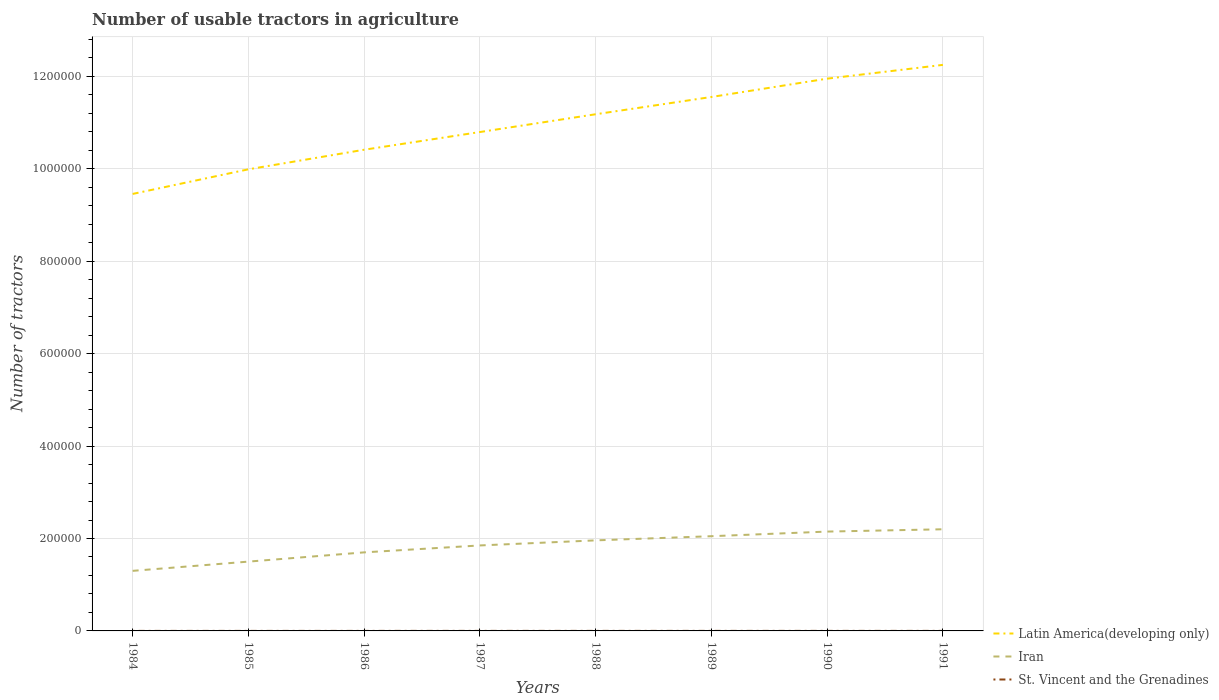How many different coloured lines are there?
Provide a short and direct response. 3. What is the total number of usable tractors in agriculture in Latin America(developing only) in the graph?
Give a very brief answer. -6.95e+04. What is the difference between the highest and the second highest number of usable tractors in agriculture in Iran?
Your answer should be compact. 9.00e+04. What is the difference between the highest and the lowest number of usable tractors in agriculture in St. Vincent and the Grenadines?
Keep it short and to the point. 4. How many lines are there?
Provide a succinct answer. 3. How many years are there in the graph?
Make the answer very short. 8. Does the graph contain grids?
Your answer should be very brief. Yes. How many legend labels are there?
Offer a very short reply. 3. What is the title of the graph?
Offer a very short reply. Number of usable tractors in agriculture. Does "Sub-Saharan Africa (developing only)" appear as one of the legend labels in the graph?
Offer a very short reply. No. What is the label or title of the X-axis?
Provide a succinct answer. Years. What is the label or title of the Y-axis?
Keep it short and to the point. Number of tractors. What is the Number of tractors of Latin America(developing only) in 1984?
Ensure brevity in your answer.  9.46e+05. What is the Number of tractors of Latin America(developing only) in 1985?
Offer a very short reply. 9.99e+05. What is the Number of tractors of Iran in 1985?
Make the answer very short. 1.50e+05. What is the Number of tractors of Latin America(developing only) in 1986?
Your answer should be very brief. 1.04e+06. What is the Number of tractors of Iran in 1986?
Provide a succinct answer. 1.70e+05. What is the Number of tractors of Latin America(developing only) in 1987?
Your answer should be compact. 1.08e+06. What is the Number of tractors in Iran in 1987?
Give a very brief answer. 1.85e+05. What is the Number of tractors in Latin America(developing only) in 1988?
Offer a very short reply. 1.12e+06. What is the Number of tractors of Iran in 1988?
Keep it short and to the point. 1.96e+05. What is the Number of tractors in Latin America(developing only) in 1989?
Ensure brevity in your answer.  1.16e+06. What is the Number of tractors of Iran in 1989?
Offer a terse response. 2.05e+05. What is the Number of tractors in St. Vincent and the Grenadines in 1989?
Keep it short and to the point. 87. What is the Number of tractors of Latin America(developing only) in 1990?
Make the answer very short. 1.20e+06. What is the Number of tractors in Iran in 1990?
Provide a short and direct response. 2.15e+05. What is the Number of tractors in St. Vincent and the Grenadines in 1990?
Your answer should be compact. 89. What is the Number of tractors of Latin America(developing only) in 1991?
Provide a short and direct response. 1.23e+06. What is the Number of tractors of Iran in 1991?
Provide a short and direct response. 2.20e+05. What is the Number of tractors in St. Vincent and the Grenadines in 1991?
Give a very brief answer. 91. Across all years, what is the maximum Number of tractors of Latin America(developing only)?
Offer a terse response. 1.23e+06. Across all years, what is the maximum Number of tractors in St. Vincent and the Grenadines?
Offer a very short reply. 91. Across all years, what is the minimum Number of tractors of Latin America(developing only)?
Offer a very short reply. 9.46e+05. Across all years, what is the minimum Number of tractors in St. Vincent and the Grenadines?
Give a very brief answer. 80. What is the total Number of tractors of Latin America(developing only) in the graph?
Provide a short and direct response. 8.76e+06. What is the total Number of tractors of Iran in the graph?
Provide a succinct answer. 1.47e+06. What is the total Number of tractors in St. Vincent and the Grenadines in the graph?
Give a very brief answer. 681. What is the difference between the Number of tractors in Latin America(developing only) in 1984 and that in 1985?
Provide a succinct answer. -5.33e+04. What is the difference between the Number of tractors in Iran in 1984 and that in 1985?
Give a very brief answer. -2.00e+04. What is the difference between the Number of tractors in St. Vincent and the Grenadines in 1984 and that in 1985?
Ensure brevity in your answer.  -1. What is the difference between the Number of tractors of Latin America(developing only) in 1984 and that in 1986?
Give a very brief answer. -9.57e+04. What is the difference between the Number of tractors in Iran in 1984 and that in 1986?
Make the answer very short. -4.00e+04. What is the difference between the Number of tractors of St. Vincent and the Grenadines in 1984 and that in 1986?
Make the answer very short. -3. What is the difference between the Number of tractors in Latin America(developing only) in 1984 and that in 1987?
Offer a very short reply. -1.34e+05. What is the difference between the Number of tractors in Iran in 1984 and that in 1987?
Make the answer very short. -5.50e+04. What is the difference between the Number of tractors of Latin America(developing only) in 1984 and that in 1988?
Offer a terse response. -1.72e+05. What is the difference between the Number of tractors in Iran in 1984 and that in 1988?
Make the answer very short. -6.60e+04. What is the difference between the Number of tractors in Latin America(developing only) in 1984 and that in 1989?
Keep it short and to the point. -2.10e+05. What is the difference between the Number of tractors of Iran in 1984 and that in 1989?
Ensure brevity in your answer.  -7.50e+04. What is the difference between the Number of tractors of Latin America(developing only) in 1984 and that in 1990?
Ensure brevity in your answer.  -2.49e+05. What is the difference between the Number of tractors of Iran in 1984 and that in 1990?
Provide a succinct answer. -8.50e+04. What is the difference between the Number of tractors in St. Vincent and the Grenadines in 1984 and that in 1990?
Offer a very short reply. -9. What is the difference between the Number of tractors of Latin America(developing only) in 1984 and that in 1991?
Make the answer very short. -2.79e+05. What is the difference between the Number of tractors in Latin America(developing only) in 1985 and that in 1986?
Offer a very short reply. -4.24e+04. What is the difference between the Number of tractors of Latin America(developing only) in 1985 and that in 1987?
Your answer should be very brief. -8.07e+04. What is the difference between the Number of tractors in Iran in 1985 and that in 1987?
Offer a terse response. -3.50e+04. What is the difference between the Number of tractors in St. Vincent and the Grenadines in 1985 and that in 1987?
Your answer should be compact. -3. What is the difference between the Number of tractors in Latin America(developing only) in 1985 and that in 1988?
Ensure brevity in your answer.  -1.19e+05. What is the difference between the Number of tractors in Iran in 1985 and that in 1988?
Give a very brief answer. -4.60e+04. What is the difference between the Number of tractors in St. Vincent and the Grenadines in 1985 and that in 1988?
Offer a very short reply. -5. What is the difference between the Number of tractors of Latin America(developing only) in 1985 and that in 1989?
Offer a very short reply. -1.57e+05. What is the difference between the Number of tractors in Iran in 1985 and that in 1989?
Provide a short and direct response. -5.50e+04. What is the difference between the Number of tractors of Latin America(developing only) in 1985 and that in 1990?
Make the answer very short. -1.96e+05. What is the difference between the Number of tractors of Iran in 1985 and that in 1990?
Provide a short and direct response. -6.50e+04. What is the difference between the Number of tractors of St. Vincent and the Grenadines in 1985 and that in 1990?
Your answer should be compact. -8. What is the difference between the Number of tractors in Latin America(developing only) in 1985 and that in 1991?
Ensure brevity in your answer.  -2.26e+05. What is the difference between the Number of tractors of Latin America(developing only) in 1986 and that in 1987?
Your answer should be very brief. -3.83e+04. What is the difference between the Number of tractors in Iran in 1986 and that in 1987?
Offer a very short reply. -1.50e+04. What is the difference between the Number of tractors in Latin America(developing only) in 1986 and that in 1988?
Provide a short and direct response. -7.68e+04. What is the difference between the Number of tractors in Iran in 1986 and that in 1988?
Offer a very short reply. -2.60e+04. What is the difference between the Number of tractors in Latin America(developing only) in 1986 and that in 1989?
Provide a short and direct response. -1.14e+05. What is the difference between the Number of tractors in Iran in 1986 and that in 1989?
Provide a short and direct response. -3.50e+04. What is the difference between the Number of tractors in St. Vincent and the Grenadines in 1986 and that in 1989?
Your answer should be compact. -4. What is the difference between the Number of tractors in Latin America(developing only) in 1986 and that in 1990?
Offer a very short reply. -1.54e+05. What is the difference between the Number of tractors in Iran in 1986 and that in 1990?
Provide a short and direct response. -4.50e+04. What is the difference between the Number of tractors of St. Vincent and the Grenadines in 1986 and that in 1990?
Provide a succinct answer. -6. What is the difference between the Number of tractors of Latin America(developing only) in 1986 and that in 1991?
Your answer should be compact. -1.84e+05. What is the difference between the Number of tractors of Latin America(developing only) in 1987 and that in 1988?
Give a very brief answer. -3.85e+04. What is the difference between the Number of tractors of Iran in 1987 and that in 1988?
Make the answer very short. -1.10e+04. What is the difference between the Number of tractors of Latin America(developing only) in 1987 and that in 1989?
Give a very brief answer. -7.59e+04. What is the difference between the Number of tractors of St. Vincent and the Grenadines in 1987 and that in 1989?
Provide a succinct answer. -3. What is the difference between the Number of tractors of Latin America(developing only) in 1987 and that in 1990?
Your answer should be compact. -1.16e+05. What is the difference between the Number of tractors in St. Vincent and the Grenadines in 1987 and that in 1990?
Your answer should be compact. -5. What is the difference between the Number of tractors of Latin America(developing only) in 1987 and that in 1991?
Your answer should be compact. -1.45e+05. What is the difference between the Number of tractors of Iran in 1987 and that in 1991?
Make the answer very short. -3.50e+04. What is the difference between the Number of tractors of St. Vincent and the Grenadines in 1987 and that in 1991?
Offer a very short reply. -7. What is the difference between the Number of tractors of Latin America(developing only) in 1988 and that in 1989?
Your answer should be compact. -3.74e+04. What is the difference between the Number of tractors of Iran in 1988 and that in 1989?
Offer a terse response. -9019. What is the difference between the Number of tractors of Latin America(developing only) in 1988 and that in 1990?
Make the answer very short. -7.70e+04. What is the difference between the Number of tractors in Iran in 1988 and that in 1990?
Your answer should be compact. -1.90e+04. What is the difference between the Number of tractors of St. Vincent and the Grenadines in 1988 and that in 1990?
Your answer should be very brief. -3. What is the difference between the Number of tractors in Latin America(developing only) in 1988 and that in 1991?
Keep it short and to the point. -1.07e+05. What is the difference between the Number of tractors in Iran in 1988 and that in 1991?
Provide a succinct answer. -2.40e+04. What is the difference between the Number of tractors of Latin America(developing only) in 1989 and that in 1990?
Provide a succinct answer. -3.96e+04. What is the difference between the Number of tractors in Iran in 1989 and that in 1990?
Give a very brief answer. -10000. What is the difference between the Number of tractors in Latin America(developing only) in 1989 and that in 1991?
Your answer should be compact. -6.95e+04. What is the difference between the Number of tractors of Iran in 1989 and that in 1991?
Provide a short and direct response. -1.50e+04. What is the difference between the Number of tractors in Latin America(developing only) in 1990 and that in 1991?
Make the answer very short. -2.98e+04. What is the difference between the Number of tractors in Iran in 1990 and that in 1991?
Offer a very short reply. -5000. What is the difference between the Number of tractors in St. Vincent and the Grenadines in 1990 and that in 1991?
Keep it short and to the point. -2. What is the difference between the Number of tractors of Latin America(developing only) in 1984 and the Number of tractors of Iran in 1985?
Your answer should be very brief. 7.96e+05. What is the difference between the Number of tractors of Latin America(developing only) in 1984 and the Number of tractors of St. Vincent and the Grenadines in 1985?
Give a very brief answer. 9.46e+05. What is the difference between the Number of tractors of Iran in 1984 and the Number of tractors of St. Vincent and the Grenadines in 1985?
Your answer should be compact. 1.30e+05. What is the difference between the Number of tractors of Latin America(developing only) in 1984 and the Number of tractors of Iran in 1986?
Your response must be concise. 7.76e+05. What is the difference between the Number of tractors of Latin America(developing only) in 1984 and the Number of tractors of St. Vincent and the Grenadines in 1986?
Keep it short and to the point. 9.46e+05. What is the difference between the Number of tractors in Iran in 1984 and the Number of tractors in St. Vincent and the Grenadines in 1986?
Ensure brevity in your answer.  1.30e+05. What is the difference between the Number of tractors in Latin America(developing only) in 1984 and the Number of tractors in Iran in 1987?
Give a very brief answer. 7.61e+05. What is the difference between the Number of tractors in Latin America(developing only) in 1984 and the Number of tractors in St. Vincent and the Grenadines in 1987?
Provide a succinct answer. 9.46e+05. What is the difference between the Number of tractors in Iran in 1984 and the Number of tractors in St. Vincent and the Grenadines in 1987?
Your response must be concise. 1.30e+05. What is the difference between the Number of tractors of Latin America(developing only) in 1984 and the Number of tractors of Iran in 1988?
Provide a succinct answer. 7.50e+05. What is the difference between the Number of tractors of Latin America(developing only) in 1984 and the Number of tractors of St. Vincent and the Grenadines in 1988?
Your answer should be very brief. 9.46e+05. What is the difference between the Number of tractors in Iran in 1984 and the Number of tractors in St. Vincent and the Grenadines in 1988?
Offer a terse response. 1.30e+05. What is the difference between the Number of tractors of Latin America(developing only) in 1984 and the Number of tractors of Iran in 1989?
Make the answer very short. 7.41e+05. What is the difference between the Number of tractors in Latin America(developing only) in 1984 and the Number of tractors in St. Vincent and the Grenadines in 1989?
Offer a terse response. 9.46e+05. What is the difference between the Number of tractors in Iran in 1984 and the Number of tractors in St. Vincent and the Grenadines in 1989?
Give a very brief answer. 1.30e+05. What is the difference between the Number of tractors of Latin America(developing only) in 1984 and the Number of tractors of Iran in 1990?
Your answer should be very brief. 7.31e+05. What is the difference between the Number of tractors in Latin America(developing only) in 1984 and the Number of tractors in St. Vincent and the Grenadines in 1990?
Offer a very short reply. 9.46e+05. What is the difference between the Number of tractors of Iran in 1984 and the Number of tractors of St. Vincent and the Grenadines in 1990?
Your response must be concise. 1.30e+05. What is the difference between the Number of tractors of Latin America(developing only) in 1984 and the Number of tractors of Iran in 1991?
Make the answer very short. 7.26e+05. What is the difference between the Number of tractors in Latin America(developing only) in 1984 and the Number of tractors in St. Vincent and the Grenadines in 1991?
Ensure brevity in your answer.  9.46e+05. What is the difference between the Number of tractors in Iran in 1984 and the Number of tractors in St. Vincent and the Grenadines in 1991?
Keep it short and to the point. 1.30e+05. What is the difference between the Number of tractors of Latin America(developing only) in 1985 and the Number of tractors of Iran in 1986?
Offer a very short reply. 8.29e+05. What is the difference between the Number of tractors of Latin America(developing only) in 1985 and the Number of tractors of St. Vincent and the Grenadines in 1986?
Your answer should be very brief. 9.99e+05. What is the difference between the Number of tractors of Iran in 1985 and the Number of tractors of St. Vincent and the Grenadines in 1986?
Your answer should be compact. 1.50e+05. What is the difference between the Number of tractors in Latin America(developing only) in 1985 and the Number of tractors in Iran in 1987?
Your answer should be very brief. 8.14e+05. What is the difference between the Number of tractors in Latin America(developing only) in 1985 and the Number of tractors in St. Vincent and the Grenadines in 1987?
Keep it short and to the point. 9.99e+05. What is the difference between the Number of tractors in Iran in 1985 and the Number of tractors in St. Vincent and the Grenadines in 1987?
Your answer should be compact. 1.50e+05. What is the difference between the Number of tractors of Latin America(developing only) in 1985 and the Number of tractors of Iran in 1988?
Make the answer very short. 8.03e+05. What is the difference between the Number of tractors in Latin America(developing only) in 1985 and the Number of tractors in St. Vincent and the Grenadines in 1988?
Make the answer very short. 9.99e+05. What is the difference between the Number of tractors of Iran in 1985 and the Number of tractors of St. Vincent and the Grenadines in 1988?
Offer a terse response. 1.50e+05. What is the difference between the Number of tractors of Latin America(developing only) in 1985 and the Number of tractors of Iran in 1989?
Keep it short and to the point. 7.94e+05. What is the difference between the Number of tractors of Latin America(developing only) in 1985 and the Number of tractors of St. Vincent and the Grenadines in 1989?
Your answer should be compact. 9.99e+05. What is the difference between the Number of tractors of Iran in 1985 and the Number of tractors of St. Vincent and the Grenadines in 1989?
Ensure brevity in your answer.  1.50e+05. What is the difference between the Number of tractors in Latin America(developing only) in 1985 and the Number of tractors in Iran in 1990?
Provide a succinct answer. 7.84e+05. What is the difference between the Number of tractors of Latin America(developing only) in 1985 and the Number of tractors of St. Vincent and the Grenadines in 1990?
Make the answer very short. 9.99e+05. What is the difference between the Number of tractors of Iran in 1985 and the Number of tractors of St. Vincent and the Grenadines in 1990?
Give a very brief answer. 1.50e+05. What is the difference between the Number of tractors of Latin America(developing only) in 1985 and the Number of tractors of Iran in 1991?
Keep it short and to the point. 7.79e+05. What is the difference between the Number of tractors in Latin America(developing only) in 1985 and the Number of tractors in St. Vincent and the Grenadines in 1991?
Your answer should be compact. 9.99e+05. What is the difference between the Number of tractors in Iran in 1985 and the Number of tractors in St. Vincent and the Grenadines in 1991?
Offer a very short reply. 1.50e+05. What is the difference between the Number of tractors in Latin America(developing only) in 1986 and the Number of tractors in Iran in 1987?
Provide a short and direct response. 8.56e+05. What is the difference between the Number of tractors in Latin America(developing only) in 1986 and the Number of tractors in St. Vincent and the Grenadines in 1987?
Offer a very short reply. 1.04e+06. What is the difference between the Number of tractors of Iran in 1986 and the Number of tractors of St. Vincent and the Grenadines in 1987?
Ensure brevity in your answer.  1.70e+05. What is the difference between the Number of tractors in Latin America(developing only) in 1986 and the Number of tractors in Iran in 1988?
Your answer should be compact. 8.45e+05. What is the difference between the Number of tractors in Latin America(developing only) in 1986 and the Number of tractors in St. Vincent and the Grenadines in 1988?
Offer a terse response. 1.04e+06. What is the difference between the Number of tractors in Iran in 1986 and the Number of tractors in St. Vincent and the Grenadines in 1988?
Give a very brief answer. 1.70e+05. What is the difference between the Number of tractors in Latin America(developing only) in 1986 and the Number of tractors in Iran in 1989?
Give a very brief answer. 8.36e+05. What is the difference between the Number of tractors in Latin America(developing only) in 1986 and the Number of tractors in St. Vincent and the Grenadines in 1989?
Provide a short and direct response. 1.04e+06. What is the difference between the Number of tractors of Iran in 1986 and the Number of tractors of St. Vincent and the Grenadines in 1989?
Give a very brief answer. 1.70e+05. What is the difference between the Number of tractors of Latin America(developing only) in 1986 and the Number of tractors of Iran in 1990?
Make the answer very short. 8.26e+05. What is the difference between the Number of tractors of Latin America(developing only) in 1986 and the Number of tractors of St. Vincent and the Grenadines in 1990?
Give a very brief answer. 1.04e+06. What is the difference between the Number of tractors in Iran in 1986 and the Number of tractors in St. Vincent and the Grenadines in 1990?
Provide a succinct answer. 1.70e+05. What is the difference between the Number of tractors of Latin America(developing only) in 1986 and the Number of tractors of Iran in 1991?
Your answer should be compact. 8.21e+05. What is the difference between the Number of tractors of Latin America(developing only) in 1986 and the Number of tractors of St. Vincent and the Grenadines in 1991?
Make the answer very short. 1.04e+06. What is the difference between the Number of tractors of Iran in 1986 and the Number of tractors of St. Vincent and the Grenadines in 1991?
Your response must be concise. 1.70e+05. What is the difference between the Number of tractors in Latin America(developing only) in 1987 and the Number of tractors in Iran in 1988?
Offer a terse response. 8.84e+05. What is the difference between the Number of tractors in Latin America(developing only) in 1987 and the Number of tractors in St. Vincent and the Grenadines in 1988?
Make the answer very short. 1.08e+06. What is the difference between the Number of tractors in Iran in 1987 and the Number of tractors in St. Vincent and the Grenadines in 1988?
Keep it short and to the point. 1.85e+05. What is the difference between the Number of tractors in Latin America(developing only) in 1987 and the Number of tractors in Iran in 1989?
Ensure brevity in your answer.  8.75e+05. What is the difference between the Number of tractors in Latin America(developing only) in 1987 and the Number of tractors in St. Vincent and the Grenadines in 1989?
Provide a short and direct response. 1.08e+06. What is the difference between the Number of tractors of Iran in 1987 and the Number of tractors of St. Vincent and the Grenadines in 1989?
Your answer should be very brief. 1.85e+05. What is the difference between the Number of tractors in Latin America(developing only) in 1987 and the Number of tractors in Iran in 1990?
Offer a very short reply. 8.65e+05. What is the difference between the Number of tractors in Latin America(developing only) in 1987 and the Number of tractors in St. Vincent and the Grenadines in 1990?
Offer a terse response. 1.08e+06. What is the difference between the Number of tractors in Iran in 1987 and the Number of tractors in St. Vincent and the Grenadines in 1990?
Offer a terse response. 1.85e+05. What is the difference between the Number of tractors in Latin America(developing only) in 1987 and the Number of tractors in Iran in 1991?
Provide a short and direct response. 8.60e+05. What is the difference between the Number of tractors of Latin America(developing only) in 1987 and the Number of tractors of St. Vincent and the Grenadines in 1991?
Provide a succinct answer. 1.08e+06. What is the difference between the Number of tractors in Iran in 1987 and the Number of tractors in St. Vincent and the Grenadines in 1991?
Give a very brief answer. 1.85e+05. What is the difference between the Number of tractors of Latin America(developing only) in 1988 and the Number of tractors of Iran in 1989?
Your answer should be compact. 9.13e+05. What is the difference between the Number of tractors in Latin America(developing only) in 1988 and the Number of tractors in St. Vincent and the Grenadines in 1989?
Provide a succinct answer. 1.12e+06. What is the difference between the Number of tractors in Iran in 1988 and the Number of tractors in St. Vincent and the Grenadines in 1989?
Provide a short and direct response. 1.96e+05. What is the difference between the Number of tractors of Latin America(developing only) in 1988 and the Number of tractors of Iran in 1990?
Your answer should be very brief. 9.03e+05. What is the difference between the Number of tractors of Latin America(developing only) in 1988 and the Number of tractors of St. Vincent and the Grenadines in 1990?
Ensure brevity in your answer.  1.12e+06. What is the difference between the Number of tractors of Iran in 1988 and the Number of tractors of St. Vincent and the Grenadines in 1990?
Offer a very short reply. 1.96e+05. What is the difference between the Number of tractors of Latin America(developing only) in 1988 and the Number of tractors of Iran in 1991?
Keep it short and to the point. 8.98e+05. What is the difference between the Number of tractors in Latin America(developing only) in 1988 and the Number of tractors in St. Vincent and the Grenadines in 1991?
Offer a very short reply. 1.12e+06. What is the difference between the Number of tractors in Iran in 1988 and the Number of tractors in St. Vincent and the Grenadines in 1991?
Your response must be concise. 1.96e+05. What is the difference between the Number of tractors in Latin America(developing only) in 1989 and the Number of tractors in Iran in 1990?
Give a very brief answer. 9.41e+05. What is the difference between the Number of tractors of Latin America(developing only) in 1989 and the Number of tractors of St. Vincent and the Grenadines in 1990?
Make the answer very short. 1.16e+06. What is the difference between the Number of tractors of Iran in 1989 and the Number of tractors of St. Vincent and the Grenadines in 1990?
Offer a terse response. 2.05e+05. What is the difference between the Number of tractors in Latin America(developing only) in 1989 and the Number of tractors in Iran in 1991?
Your answer should be compact. 9.36e+05. What is the difference between the Number of tractors in Latin America(developing only) in 1989 and the Number of tractors in St. Vincent and the Grenadines in 1991?
Give a very brief answer. 1.16e+06. What is the difference between the Number of tractors of Iran in 1989 and the Number of tractors of St. Vincent and the Grenadines in 1991?
Offer a very short reply. 2.05e+05. What is the difference between the Number of tractors of Latin America(developing only) in 1990 and the Number of tractors of Iran in 1991?
Your answer should be compact. 9.75e+05. What is the difference between the Number of tractors in Latin America(developing only) in 1990 and the Number of tractors in St. Vincent and the Grenadines in 1991?
Offer a terse response. 1.20e+06. What is the difference between the Number of tractors in Iran in 1990 and the Number of tractors in St. Vincent and the Grenadines in 1991?
Provide a short and direct response. 2.15e+05. What is the average Number of tractors of Latin America(developing only) per year?
Provide a succinct answer. 1.10e+06. What is the average Number of tractors of Iran per year?
Offer a terse response. 1.84e+05. What is the average Number of tractors in St. Vincent and the Grenadines per year?
Your answer should be very brief. 85.12. In the year 1984, what is the difference between the Number of tractors of Latin America(developing only) and Number of tractors of Iran?
Offer a terse response. 8.16e+05. In the year 1984, what is the difference between the Number of tractors of Latin America(developing only) and Number of tractors of St. Vincent and the Grenadines?
Keep it short and to the point. 9.46e+05. In the year 1984, what is the difference between the Number of tractors of Iran and Number of tractors of St. Vincent and the Grenadines?
Offer a terse response. 1.30e+05. In the year 1985, what is the difference between the Number of tractors of Latin America(developing only) and Number of tractors of Iran?
Your response must be concise. 8.49e+05. In the year 1985, what is the difference between the Number of tractors of Latin America(developing only) and Number of tractors of St. Vincent and the Grenadines?
Provide a succinct answer. 9.99e+05. In the year 1985, what is the difference between the Number of tractors in Iran and Number of tractors in St. Vincent and the Grenadines?
Make the answer very short. 1.50e+05. In the year 1986, what is the difference between the Number of tractors in Latin America(developing only) and Number of tractors in Iran?
Offer a very short reply. 8.71e+05. In the year 1986, what is the difference between the Number of tractors in Latin America(developing only) and Number of tractors in St. Vincent and the Grenadines?
Your response must be concise. 1.04e+06. In the year 1986, what is the difference between the Number of tractors of Iran and Number of tractors of St. Vincent and the Grenadines?
Make the answer very short. 1.70e+05. In the year 1987, what is the difference between the Number of tractors in Latin America(developing only) and Number of tractors in Iran?
Your answer should be very brief. 8.95e+05. In the year 1987, what is the difference between the Number of tractors in Latin America(developing only) and Number of tractors in St. Vincent and the Grenadines?
Provide a short and direct response. 1.08e+06. In the year 1987, what is the difference between the Number of tractors of Iran and Number of tractors of St. Vincent and the Grenadines?
Offer a terse response. 1.85e+05. In the year 1988, what is the difference between the Number of tractors in Latin America(developing only) and Number of tractors in Iran?
Give a very brief answer. 9.22e+05. In the year 1988, what is the difference between the Number of tractors in Latin America(developing only) and Number of tractors in St. Vincent and the Grenadines?
Your answer should be very brief. 1.12e+06. In the year 1988, what is the difference between the Number of tractors in Iran and Number of tractors in St. Vincent and the Grenadines?
Your response must be concise. 1.96e+05. In the year 1989, what is the difference between the Number of tractors of Latin America(developing only) and Number of tractors of Iran?
Offer a terse response. 9.51e+05. In the year 1989, what is the difference between the Number of tractors of Latin America(developing only) and Number of tractors of St. Vincent and the Grenadines?
Provide a short and direct response. 1.16e+06. In the year 1989, what is the difference between the Number of tractors in Iran and Number of tractors in St. Vincent and the Grenadines?
Your answer should be very brief. 2.05e+05. In the year 1990, what is the difference between the Number of tractors of Latin America(developing only) and Number of tractors of Iran?
Offer a very short reply. 9.80e+05. In the year 1990, what is the difference between the Number of tractors in Latin America(developing only) and Number of tractors in St. Vincent and the Grenadines?
Your answer should be compact. 1.20e+06. In the year 1990, what is the difference between the Number of tractors in Iran and Number of tractors in St. Vincent and the Grenadines?
Provide a succinct answer. 2.15e+05. In the year 1991, what is the difference between the Number of tractors in Latin America(developing only) and Number of tractors in Iran?
Offer a very short reply. 1.01e+06. In the year 1991, what is the difference between the Number of tractors in Latin America(developing only) and Number of tractors in St. Vincent and the Grenadines?
Offer a terse response. 1.22e+06. In the year 1991, what is the difference between the Number of tractors in Iran and Number of tractors in St. Vincent and the Grenadines?
Your response must be concise. 2.20e+05. What is the ratio of the Number of tractors of Latin America(developing only) in 1984 to that in 1985?
Make the answer very short. 0.95. What is the ratio of the Number of tractors of Iran in 1984 to that in 1985?
Your answer should be compact. 0.87. What is the ratio of the Number of tractors of St. Vincent and the Grenadines in 1984 to that in 1985?
Your answer should be very brief. 0.99. What is the ratio of the Number of tractors of Latin America(developing only) in 1984 to that in 1986?
Your response must be concise. 0.91. What is the ratio of the Number of tractors of Iran in 1984 to that in 1986?
Your response must be concise. 0.76. What is the ratio of the Number of tractors in St. Vincent and the Grenadines in 1984 to that in 1986?
Make the answer very short. 0.96. What is the ratio of the Number of tractors in Latin America(developing only) in 1984 to that in 1987?
Offer a very short reply. 0.88. What is the ratio of the Number of tractors of Iran in 1984 to that in 1987?
Your answer should be compact. 0.7. What is the ratio of the Number of tractors of St. Vincent and the Grenadines in 1984 to that in 1987?
Your answer should be compact. 0.95. What is the ratio of the Number of tractors in Latin America(developing only) in 1984 to that in 1988?
Ensure brevity in your answer.  0.85. What is the ratio of the Number of tractors of Iran in 1984 to that in 1988?
Give a very brief answer. 0.66. What is the ratio of the Number of tractors in St. Vincent and the Grenadines in 1984 to that in 1988?
Ensure brevity in your answer.  0.93. What is the ratio of the Number of tractors in Latin America(developing only) in 1984 to that in 1989?
Make the answer very short. 0.82. What is the ratio of the Number of tractors of Iran in 1984 to that in 1989?
Offer a terse response. 0.63. What is the ratio of the Number of tractors in St. Vincent and the Grenadines in 1984 to that in 1989?
Provide a succinct answer. 0.92. What is the ratio of the Number of tractors in Latin America(developing only) in 1984 to that in 1990?
Your answer should be very brief. 0.79. What is the ratio of the Number of tractors in Iran in 1984 to that in 1990?
Your answer should be very brief. 0.6. What is the ratio of the Number of tractors in St. Vincent and the Grenadines in 1984 to that in 1990?
Ensure brevity in your answer.  0.9. What is the ratio of the Number of tractors in Latin America(developing only) in 1984 to that in 1991?
Your response must be concise. 0.77. What is the ratio of the Number of tractors of Iran in 1984 to that in 1991?
Make the answer very short. 0.59. What is the ratio of the Number of tractors in St. Vincent and the Grenadines in 1984 to that in 1991?
Give a very brief answer. 0.88. What is the ratio of the Number of tractors of Latin America(developing only) in 1985 to that in 1986?
Provide a succinct answer. 0.96. What is the ratio of the Number of tractors in Iran in 1985 to that in 1986?
Give a very brief answer. 0.88. What is the ratio of the Number of tractors in St. Vincent and the Grenadines in 1985 to that in 1986?
Give a very brief answer. 0.98. What is the ratio of the Number of tractors of Latin America(developing only) in 1985 to that in 1987?
Offer a very short reply. 0.93. What is the ratio of the Number of tractors of Iran in 1985 to that in 1987?
Offer a very short reply. 0.81. What is the ratio of the Number of tractors of Latin America(developing only) in 1985 to that in 1988?
Offer a terse response. 0.89. What is the ratio of the Number of tractors in Iran in 1985 to that in 1988?
Your answer should be very brief. 0.77. What is the ratio of the Number of tractors of St. Vincent and the Grenadines in 1985 to that in 1988?
Your answer should be compact. 0.94. What is the ratio of the Number of tractors of Latin America(developing only) in 1985 to that in 1989?
Your answer should be very brief. 0.86. What is the ratio of the Number of tractors of Iran in 1985 to that in 1989?
Give a very brief answer. 0.73. What is the ratio of the Number of tractors of St. Vincent and the Grenadines in 1985 to that in 1989?
Provide a short and direct response. 0.93. What is the ratio of the Number of tractors of Latin America(developing only) in 1985 to that in 1990?
Give a very brief answer. 0.84. What is the ratio of the Number of tractors in Iran in 1985 to that in 1990?
Make the answer very short. 0.7. What is the ratio of the Number of tractors in St. Vincent and the Grenadines in 1985 to that in 1990?
Your answer should be compact. 0.91. What is the ratio of the Number of tractors of Latin America(developing only) in 1985 to that in 1991?
Your answer should be very brief. 0.82. What is the ratio of the Number of tractors in Iran in 1985 to that in 1991?
Offer a very short reply. 0.68. What is the ratio of the Number of tractors in St. Vincent and the Grenadines in 1985 to that in 1991?
Make the answer very short. 0.89. What is the ratio of the Number of tractors in Latin America(developing only) in 1986 to that in 1987?
Provide a succinct answer. 0.96. What is the ratio of the Number of tractors of Iran in 1986 to that in 1987?
Give a very brief answer. 0.92. What is the ratio of the Number of tractors of Latin America(developing only) in 1986 to that in 1988?
Ensure brevity in your answer.  0.93. What is the ratio of the Number of tractors in Iran in 1986 to that in 1988?
Ensure brevity in your answer.  0.87. What is the ratio of the Number of tractors of St. Vincent and the Grenadines in 1986 to that in 1988?
Offer a terse response. 0.97. What is the ratio of the Number of tractors of Latin America(developing only) in 1986 to that in 1989?
Offer a very short reply. 0.9. What is the ratio of the Number of tractors in Iran in 1986 to that in 1989?
Keep it short and to the point. 0.83. What is the ratio of the Number of tractors of St. Vincent and the Grenadines in 1986 to that in 1989?
Keep it short and to the point. 0.95. What is the ratio of the Number of tractors in Latin America(developing only) in 1986 to that in 1990?
Make the answer very short. 0.87. What is the ratio of the Number of tractors of Iran in 1986 to that in 1990?
Your answer should be compact. 0.79. What is the ratio of the Number of tractors of St. Vincent and the Grenadines in 1986 to that in 1990?
Keep it short and to the point. 0.93. What is the ratio of the Number of tractors in Latin America(developing only) in 1986 to that in 1991?
Your response must be concise. 0.85. What is the ratio of the Number of tractors in Iran in 1986 to that in 1991?
Give a very brief answer. 0.77. What is the ratio of the Number of tractors of St. Vincent and the Grenadines in 1986 to that in 1991?
Offer a terse response. 0.91. What is the ratio of the Number of tractors in Latin America(developing only) in 1987 to that in 1988?
Offer a very short reply. 0.97. What is the ratio of the Number of tractors in Iran in 1987 to that in 1988?
Make the answer very short. 0.94. What is the ratio of the Number of tractors in St. Vincent and the Grenadines in 1987 to that in 1988?
Offer a terse response. 0.98. What is the ratio of the Number of tractors of Latin America(developing only) in 1987 to that in 1989?
Your answer should be very brief. 0.93. What is the ratio of the Number of tractors of Iran in 1987 to that in 1989?
Your answer should be compact. 0.9. What is the ratio of the Number of tractors in St. Vincent and the Grenadines in 1987 to that in 1989?
Offer a terse response. 0.97. What is the ratio of the Number of tractors in Latin America(developing only) in 1987 to that in 1990?
Provide a succinct answer. 0.9. What is the ratio of the Number of tractors in Iran in 1987 to that in 1990?
Your answer should be compact. 0.86. What is the ratio of the Number of tractors in St. Vincent and the Grenadines in 1987 to that in 1990?
Offer a very short reply. 0.94. What is the ratio of the Number of tractors of Latin America(developing only) in 1987 to that in 1991?
Ensure brevity in your answer.  0.88. What is the ratio of the Number of tractors of Iran in 1987 to that in 1991?
Offer a terse response. 0.84. What is the ratio of the Number of tractors of St. Vincent and the Grenadines in 1987 to that in 1991?
Your response must be concise. 0.92. What is the ratio of the Number of tractors in Latin America(developing only) in 1988 to that in 1989?
Give a very brief answer. 0.97. What is the ratio of the Number of tractors in Iran in 1988 to that in 1989?
Your answer should be very brief. 0.96. What is the ratio of the Number of tractors of St. Vincent and the Grenadines in 1988 to that in 1989?
Your answer should be compact. 0.99. What is the ratio of the Number of tractors of Latin America(developing only) in 1988 to that in 1990?
Offer a terse response. 0.94. What is the ratio of the Number of tractors in Iran in 1988 to that in 1990?
Your response must be concise. 0.91. What is the ratio of the Number of tractors of St. Vincent and the Grenadines in 1988 to that in 1990?
Your answer should be compact. 0.97. What is the ratio of the Number of tractors of Latin America(developing only) in 1988 to that in 1991?
Offer a terse response. 0.91. What is the ratio of the Number of tractors in Iran in 1988 to that in 1991?
Give a very brief answer. 0.89. What is the ratio of the Number of tractors in St. Vincent and the Grenadines in 1988 to that in 1991?
Provide a short and direct response. 0.95. What is the ratio of the Number of tractors in Latin America(developing only) in 1989 to that in 1990?
Your answer should be compact. 0.97. What is the ratio of the Number of tractors in Iran in 1989 to that in 1990?
Your answer should be compact. 0.95. What is the ratio of the Number of tractors in St. Vincent and the Grenadines in 1989 to that in 1990?
Provide a short and direct response. 0.98. What is the ratio of the Number of tractors of Latin America(developing only) in 1989 to that in 1991?
Ensure brevity in your answer.  0.94. What is the ratio of the Number of tractors of Iran in 1989 to that in 1991?
Ensure brevity in your answer.  0.93. What is the ratio of the Number of tractors in St. Vincent and the Grenadines in 1989 to that in 1991?
Give a very brief answer. 0.96. What is the ratio of the Number of tractors in Latin America(developing only) in 1990 to that in 1991?
Provide a succinct answer. 0.98. What is the ratio of the Number of tractors of Iran in 1990 to that in 1991?
Ensure brevity in your answer.  0.98. What is the difference between the highest and the second highest Number of tractors in Latin America(developing only)?
Provide a short and direct response. 2.98e+04. What is the difference between the highest and the second highest Number of tractors in St. Vincent and the Grenadines?
Your answer should be very brief. 2. What is the difference between the highest and the lowest Number of tractors of Latin America(developing only)?
Offer a terse response. 2.79e+05. What is the difference between the highest and the lowest Number of tractors in Iran?
Offer a terse response. 9.00e+04. 